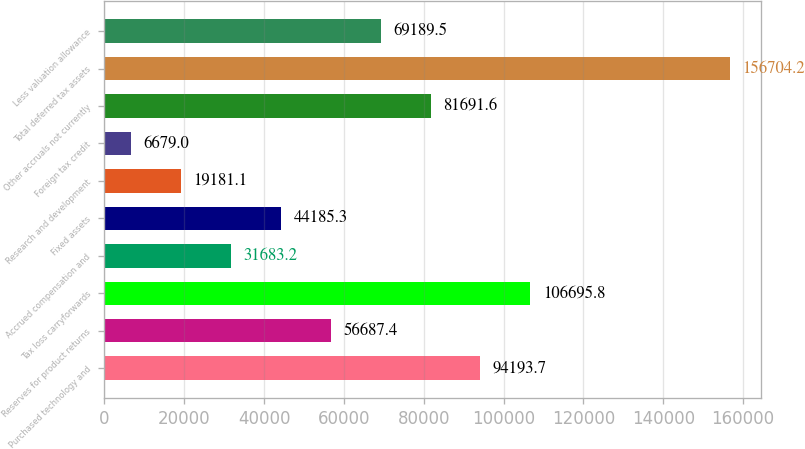<chart> <loc_0><loc_0><loc_500><loc_500><bar_chart><fcel>Purchased technology and<fcel>Reserves for product returns<fcel>Tax loss carryforwards<fcel>Accrued compensation and<fcel>Fixed assets<fcel>Research and development<fcel>Foreign tax credit<fcel>Other accruals not currently<fcel>Total deferred tax assets<fcel>Less valuation allowance<nl><fcel>94193.7<fcel>56687.4<fcel>106696<fcel>31683.2<fcel>44185.3<fcel>19181.1<fcel>6679<fcel>81691.6<fcel>156704<fcel>69189.5<nl></chart> 